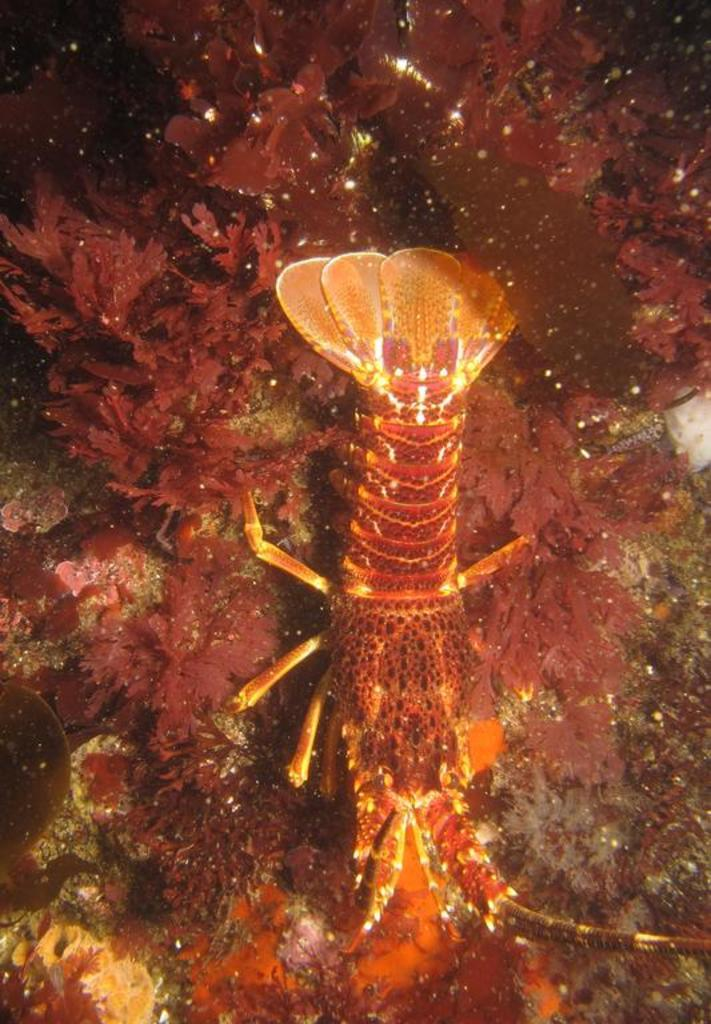What type of animal is in the picture? There is a reptile in the picture. What is surrounding the reptile in the image? There are small plants around the reptile. What type of pain is the reptile experiencing in the image? There is no indication of pain or discomfort in the image; the reptile appears to be in its natural environment. 